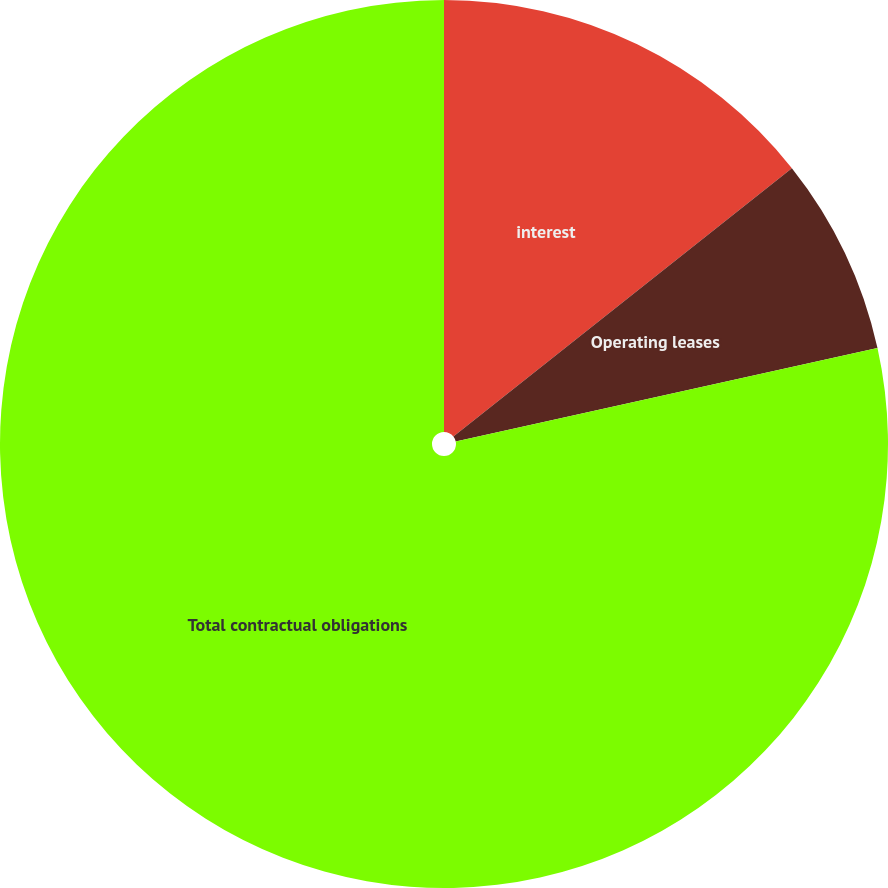<chart> <loc_0><loc_0><loc_500><loc_500><pie_chart><fcel>interest<fcel>Operating leases<fcel>Total contractual obligations<nl><fcel>14.33%<fcel>7.2%<fcel>78.47%<nl></chart> 